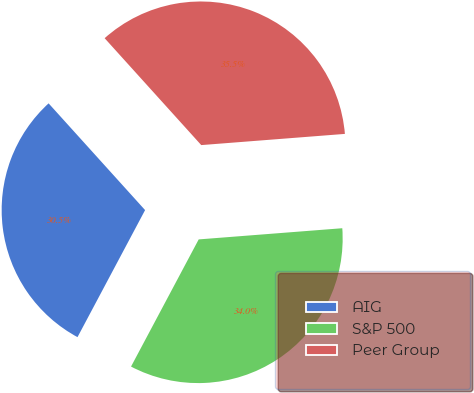<chart> <loc_0><loc_0><loc_500><loc_500><pie_chart><fcel>AIG<fcel>S&P 500<fcel>Peer Group<nl><fcel>30.52%<fcel>34.02%<fcel>35.46%<nl></chart> 